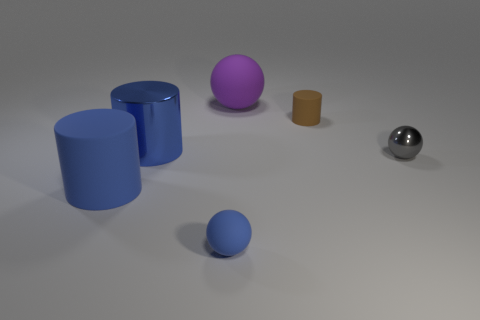Add 3 red matte things. How many objects exist? 9 Subtract 0 brown balls. How many objects are left? 6 Subtract all purple spheres. Subtract all gray spheres. How many objects are left? 4 Add 6 small cylinders. How many small cylinders are left? 7 Add 6 large purple matte things. How many large purple matte things exist? 7 